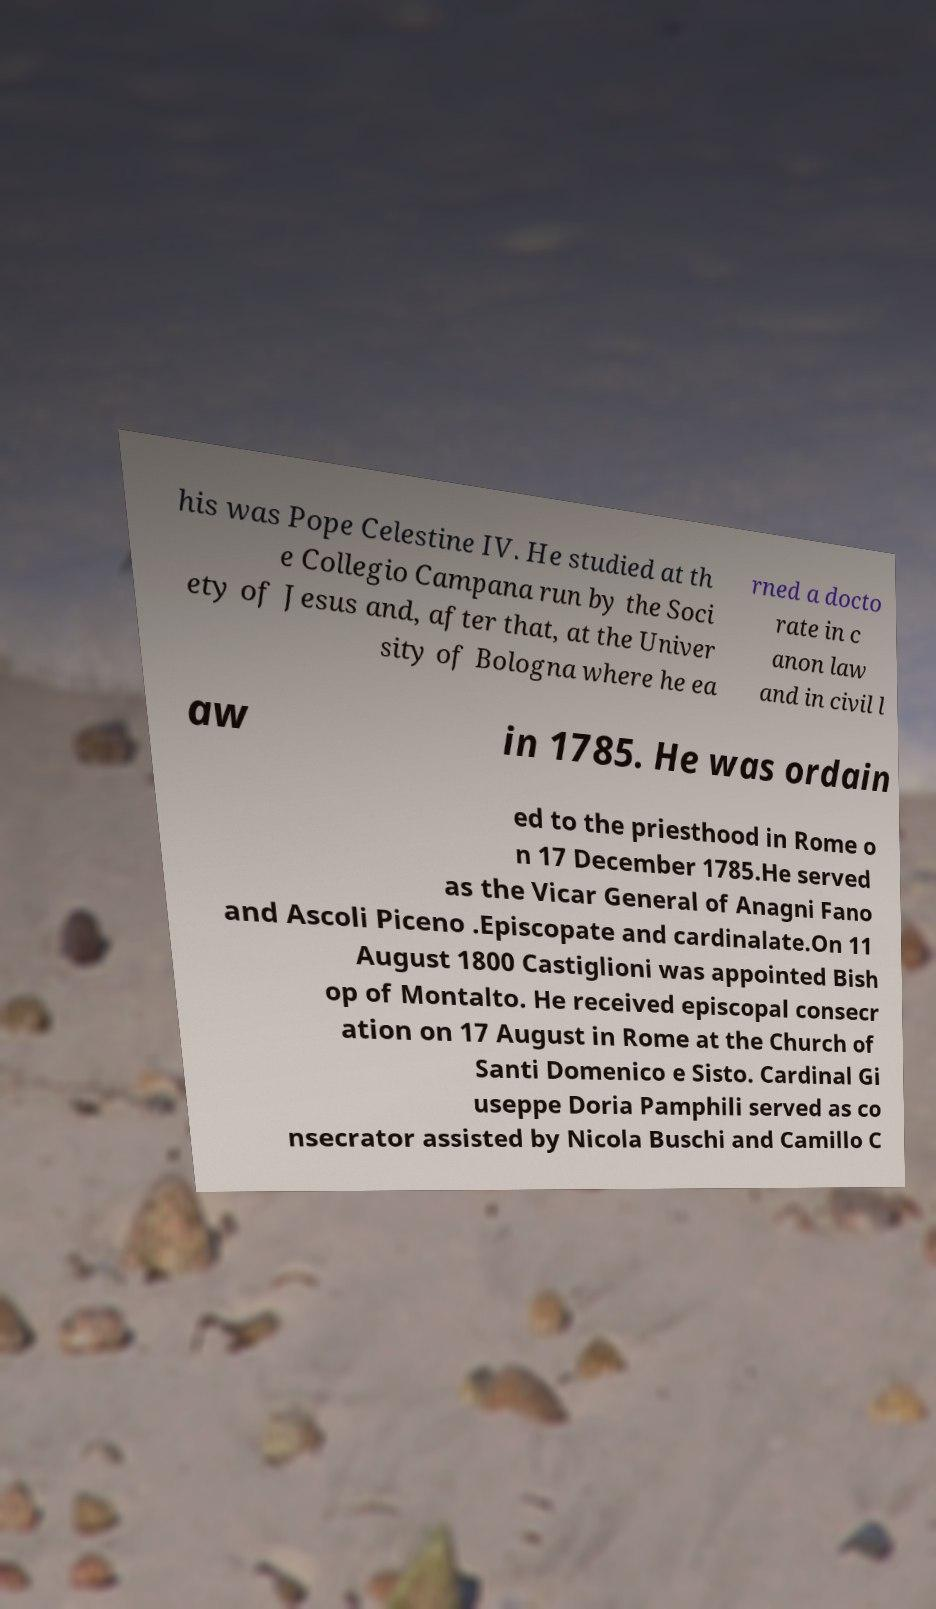Could you assist in decoding the text presented in this image and type it out clearly? his was Pope Celestine IV. He studied at th e Collegio Campana run by the Soci ety of Jesus and, after that, at the Univer sity of Bologna where he ea rned a docto rate in c anon law and in civil l aw in 1785. He was ordain ed to the priesthood in Rome o n 17 December 1785.He served as the Vicar General of Anagni Fano and Ascoli Piceno .Episcopate and cardinalate.On 11 August 1800 Castiglioni was appointed Bish op of Montalto. He received episcopal consecr ation on 17 August in Rome at the Church of Santi Domenico e Sisto. Cardinal Gi useppe Doria Pamphili served as co nsecrator assisted by Nicola Buschi and Camillo C 